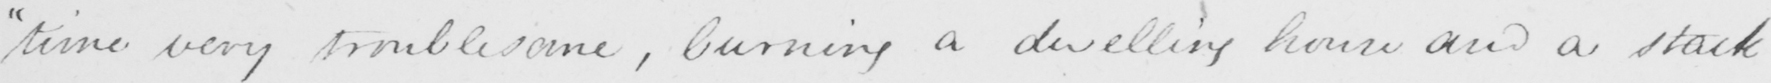Can you tell me what this handwritten text says? " time very troublesome , burning a dwelling house and a stack 